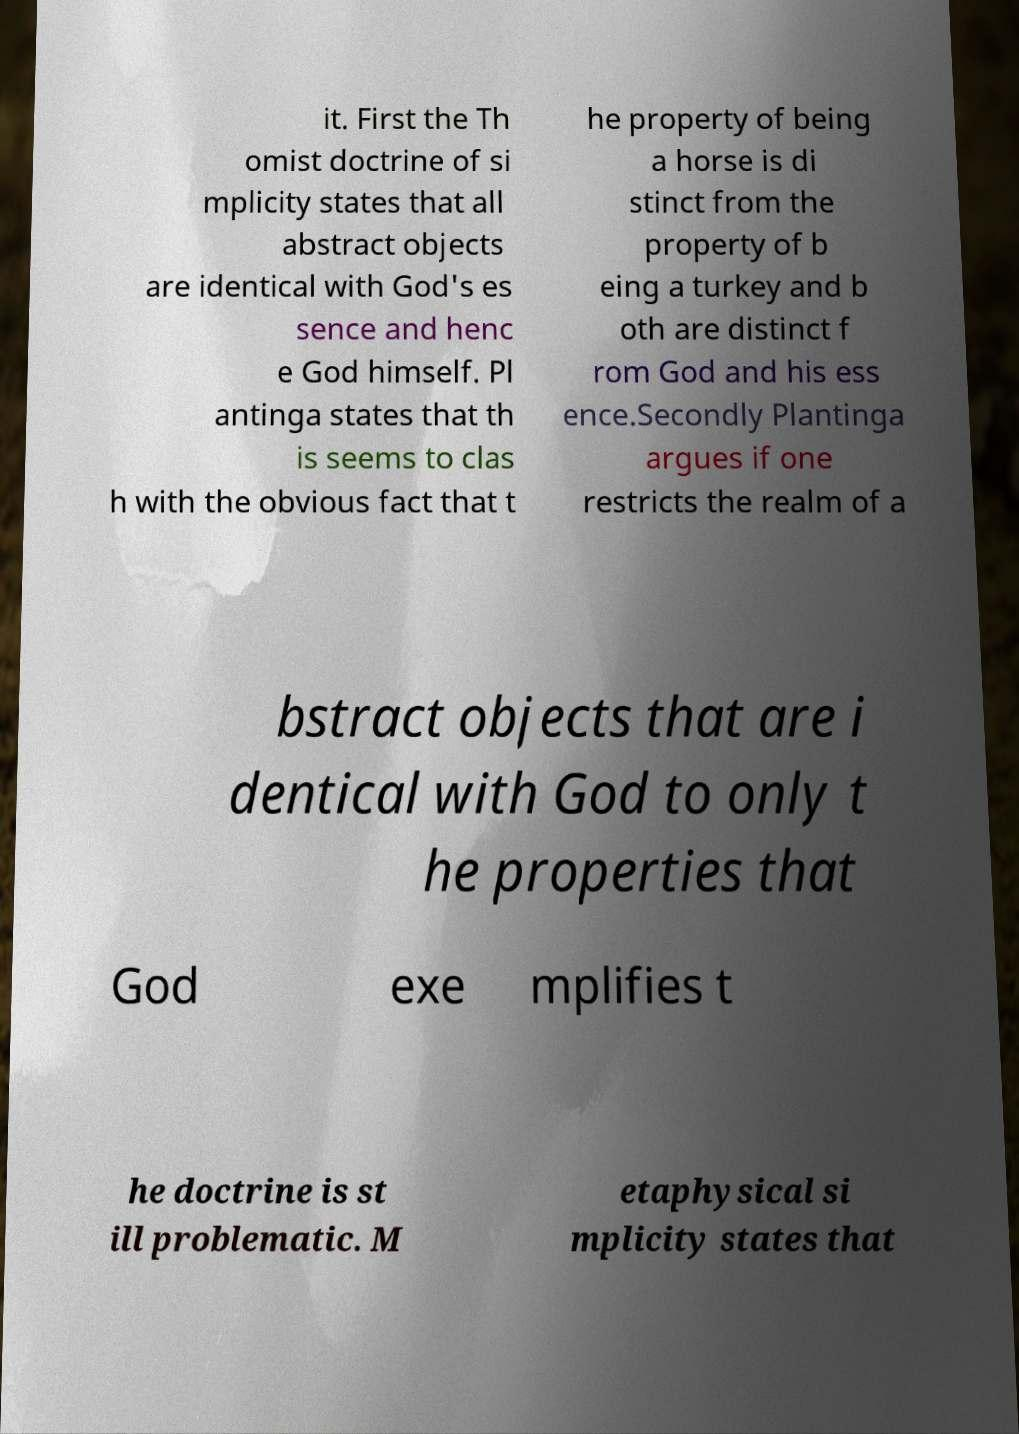For documentation purposes, I need the text within this image transcribed. Could you provide that? it. First the Th omist doctrine of si mplicity states that all abstract objects are identical with God's es sence and henc e God himself. Pl antinga states that th is seems to clas h with the obvious fact that t he property of being a horse is di stinct from the property of b eing a turkey and b oth are distinct f rom God and his ess ence.Secondly Plantinga argues if one restricts the realm of a bstract objects that are i dentical with God to only t he properties that God exe mplifies t he doctrine is st ill problematic. M etaphysical si mplicity states that 